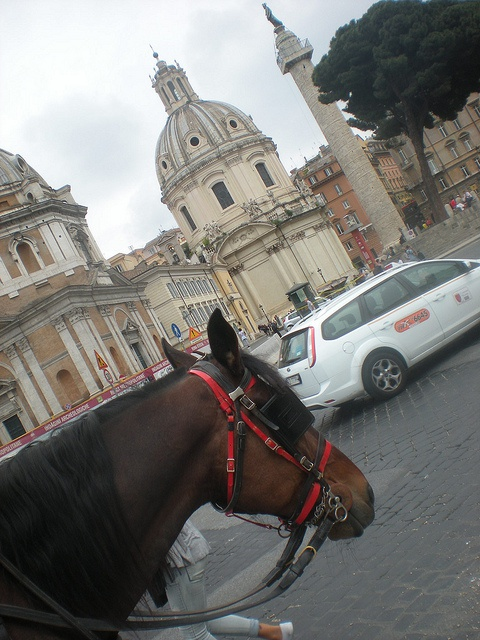Describe the objects in this image and their specific colors. I can see horse in white, black, maroon, and gray tones, car in white, darkgray, lightgray, and gray tones, people in white, gray, black, and purple tones, people in white, gray, darkgray, and lightgray tones, and car in white, darkgray, lightgray, and gray tones in this image. 